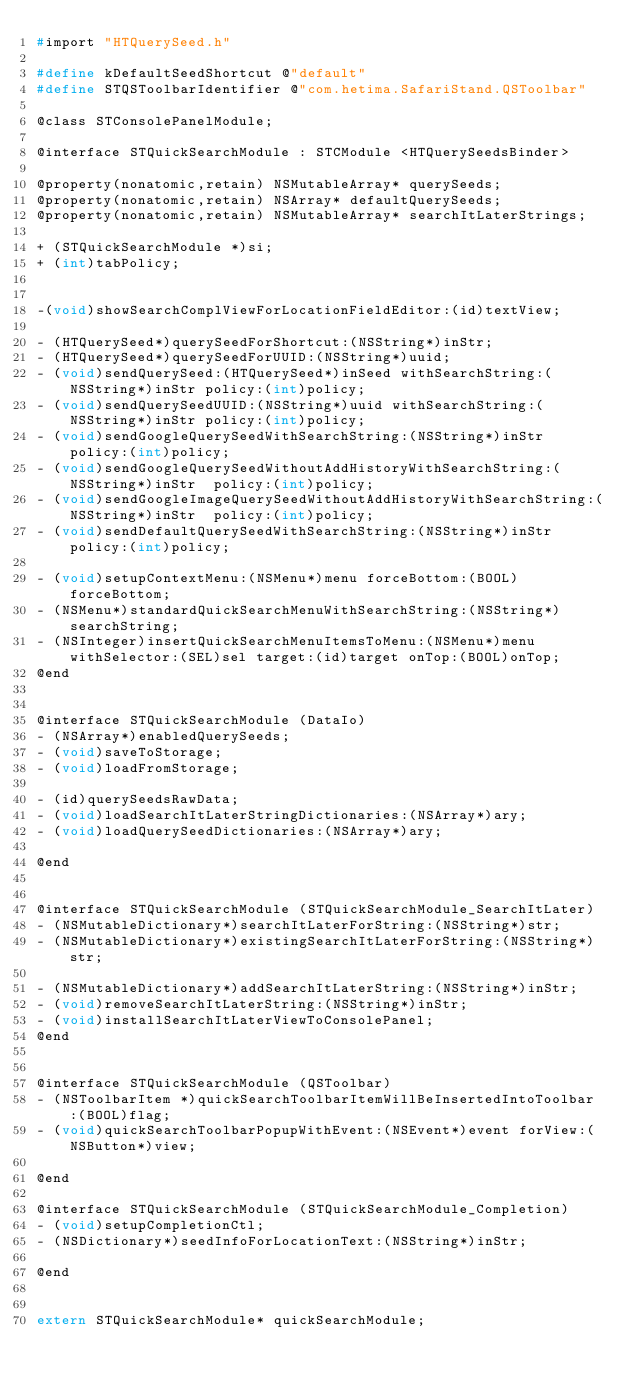Convert code to text. <code><loc_0><loc_0><loc_500><loc_500><_C_>#import "HTQuerySeed.h"

#define kDefaultSeedShortcut @"default"
#define STQSToolbarIdentifier @"com.hetima.SafariStand.QSToolbar"

@class STConsolePanelModule;

@interface STQuickSearchModule : STCModule <HTQuerySeedsBinder>

@property(nonatomic,retain) NSMutableArray* querySeeds;
@property(nonatomic,retain) NSArray* defaultQuerySeeds;
@property(nonatomic,retain) NSMutableArray* searchItLaterStrings;

+ (STQuickSearchModule *)si;
+ (int)tabPolicy;


-(void)showSearchComplViewForLocationFieldEditor:(id)textView;

- (HTQuerySeed*)querySeedForShortcut:(NSString*)inStr;
- (HTQuerySeed*)querySeedForUUID:(NSString*)uuid;
- (void)sendQuerySeed:(HTQuerySeed*)inSeed withSearchString:(NSString*)inStr policy:(int)policy;
- (void)sendQuerySeedUUID:(NSString*)uuid withSearchString:(NSString*)inStr policy:(int)policy;
- (void)sendGoogleQuerySeedWithSearchString:(NSString*)inStr  policy:(int)policy;
- (void)sendGoogleQuerySeedWithoutAddHistoryWithSearchString:(NSString*)inStr  policy:(int)policy;
- (void)sendGoogleImageQuerySeedWithoutAddHistoryWithSearchString:(NSString*)inStr  policy:(int)policy;
- (void)sendDefaultQuerySeedWithSearchString:(NSString*)inStr  policy:(int)policy;

- (void)setupContextMenu:(NSMenu*)menu forceBottom:(BOOL)forceBottom;
- (NSMenu*)standardQuickSearchMenuWithSearchString:(NSString*)searchString;
- (NSInteger)insertQuickSearchMenuItemsToMenu:(NSMenu*)menu withSelector:(SEL)sel target:(id)target onTop:(BOOL)onTop;
@end


@interface STQuickSearchModule (DataIo)
- (NSArray*)enabledQuerySeeds;
- (void)saveToStorage;
- (void)loadFromStorage;

- (id)querySeedsRawData;
- (void)loadSearchItLaterStringDictionaries:(NSArray*)ary;
- (void)loadQuerySeedDictionaries:(NSArray*)ary;

@end


@interface STQuickSearchModule (STQuickSearchModule_SearchItLater)
- (NSMutableDictionary*)searchItLaterForString:(NSString*)str;
- (NSMutableDictionary*)existingSearchItLaterForString:(NSString*)str;

- (NSMutableDictionary*)addSearchItLaterString:(NSString*)inStr;
- (void)removeSearchItLaterString:(NSString*)inStr;
- (void)installSearchItLaterViewToConsolePanel;
@end


@interface STQuickSearchModule (QSToolbar)
- (NSToolbarItem *)quickSearchToolbarItemWillBeInsertedIntoToolbar:(BOOL)flag;
- (void)quickSearchToolbarPopupWithEvent:(NSEvent*)event forView:(NSButton*)view;

@end

@interface STQuickSearchModule (STQuickSearchModule_Completion)
- (void)setupCompletionCtl;
- (NSDictionary*)seedInfoForLocationText:(NSString*)inStr;

@end


extern STQuickSearchModule* quickSearchModule;

</code> 